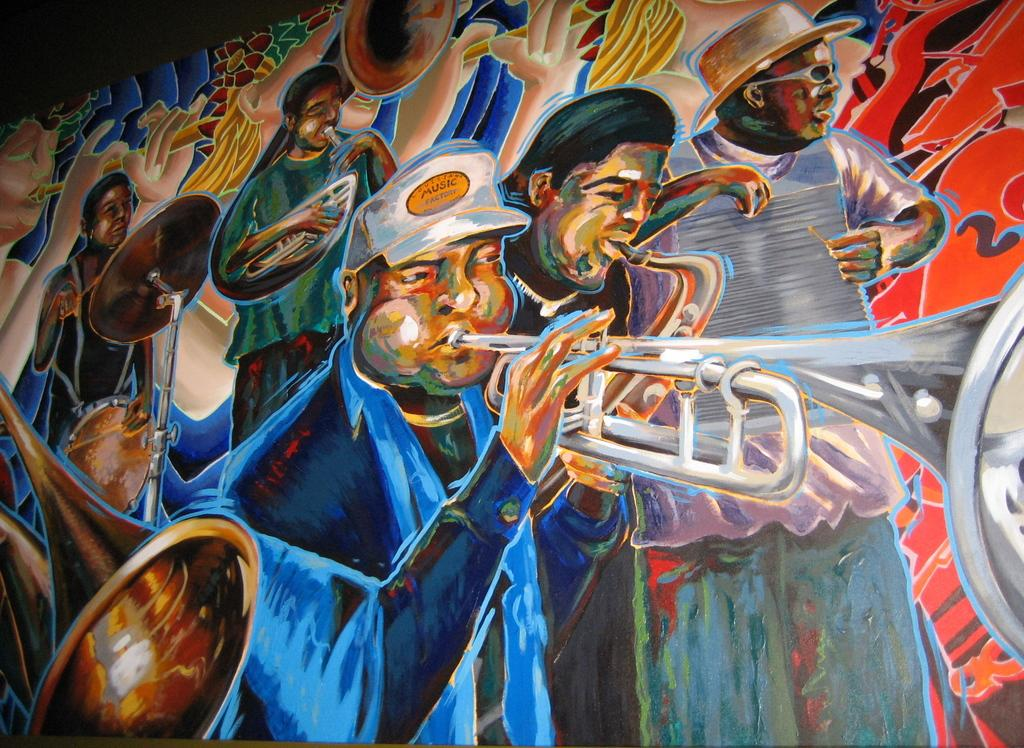What is the main subject of the image? There is a painting in the image. What is depicted in the painting? The painting contains people. What are the people in the painting doing? The people in the painting are playing musical instruments. instruments. What type of grape is being used as a temper in the painting? There is no grape or temper present in the painting; it features people playing musical instruments. 